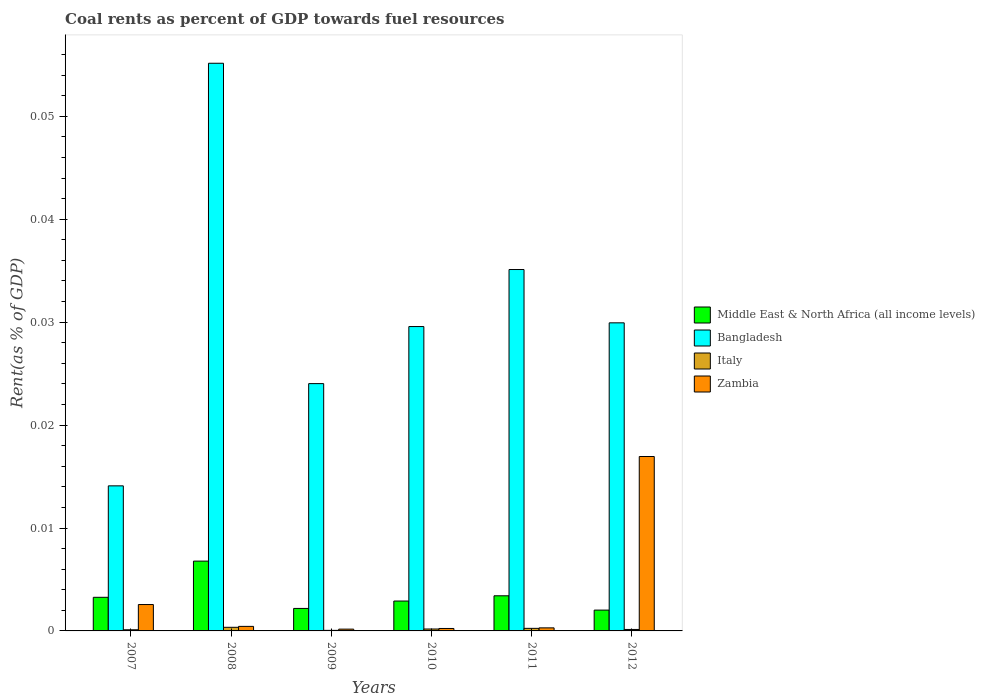How many different coloured bars are there?
Keep it short and to the point. 4. Are the number of bars per tick equal to the number of legend labels?
Offer a terse response. Yes. How many bars are there on the 6th tick from the left?
Keep it short and to the point. 4. How many bars are there on the 1st tick from the right?
Your answer should be very brief. 4. What is the coal rent in Bangladesh in 2007?
Offer a terse response. 0.01. Across all years, what is the maximum coal rent in Bangladesh?
Your answer should be very brief. 0.06. Across all years, what is the minimum coal rent in Italy?
Give a very brief answer. 5.380155600468061e-5. In which year was the coal rent in Italy maximum?
Your response must be concise. 2008. What is the total coal rent in Bangladesh in the graph?
Offer a terse response. 0.19. What is the difference between the coal rent in Italy in 2009 and that in 2011?
Your response must be concise. -0. What is the difference between the coal rent in Bangladesh in 2008 and the coal rent in Middle East & North Africa (all income levels) in 2009?
Offer a terse response. 0.05. What is the average coal rent in Italy per year?
Provide a succinct answer. 0. In the year 2012, what is the difference between the coal rent in Italy and coal rent in Zambia?
Keep it short and to the point. -0.02. In how many years, is the coal rent in Italy greater than 0.052000000000000005 %?
Make the answer very short. 0. What is the ratio of the coal rent in Italy in 2010 to that in 2011?
Offer a very short reply. 0.75. Is the coal rent in Bangladesh in 2010 less than that in 2012?
Offer a terse response. Yes. Is the difference between the coal rent in Italy in 2007 and 2010 greater than the difference between the coal rent in Zambia in 2007 and 2010?
Your answer should be very brief. No. What is the difference between the highest and the second highest coal rent in Bangladesh?
Your answer should be very brief. 0.02. What is the difference between the highest and the lowest coal rent in Zambia?
Your answer should be compact. 0.02. In how many years, is the coal rent in Italy greater than the average coal rent in Italy taken over all years?
Give a very brief answer. 3. Is the sum of the coal rent in Bangladesh in 2008 and 2009 greater than the maximum coal rent in Middle East & North Africa (all income levels) across all years?
Your answer should be very brief. Yes. Is it the case that in every year, the sum of the coal rent in Zambia and coal rent in Bangladesh is greater than the sum of coal rent in Italy and coal rent in Middle East & North Africa (all income levels)?
Provide a short and direct response. Yes. What does the 1st bar from the left in 2010 represents?
Your answer should be very brief. Middle East & North Africa (all income levels). What does the 1st bar from the right in 2007 represents?
Keep it short and to the point. Zambia. How many years are there in the graph?
Provide a short and direct response. 6. What is the difference between two consecutive major ticks on the Y-axis?
Ensure brevity in your answer.  0.01. Are the values on the major ticks of Y-axis written in scientific E-notation?
Provide a short and direct response. No. Does the graph contain any zero values?
Offer a terse response. No. Where does the legend appear in the graph?
Offer a terse response. Center right. How many legend labels are there?
Give a very brief answer. 4. How are the legend labels stacked?
Make the answer very short. Vertical. What is the title of the graph?
Offer a terse response. Coal rents as percent of GDP towards fuel resources. What is the label or title of the X-axis?
Make the answer very short. Years. What is the label or title of the Y-axis?
Your response must be concise. Rent(as % of GDP). What is the Rent(as % of GDP) of Middle East & North Africa (all income levels) in 2007?
Make the answer very short. 0. What is the Rent(as % of GDP) of Bangladesh in 2007?
Your answer should be very brief. 0.01. What is the Rent(as % of GDP) of Italy in 2007?
Keep it short and to the point. 0. What is the Rent(as % of GDP) of Zambia in 2007?
Offer a terse response. 0. What is the Rent(as % of GDP) in Middle East & North Africa (all income levels) in 2008?
Your answer should be very brief. 0.01. What is the Rent(as % of GDP) in Bangladesh in 2008?
Give a very brief answer. 0.06. What is the Rent(as % of GDP) in Italy in 2008?
Ensure brevity in your answer.  0. What is the Rent(as % of GDP) in Zambia in 2008?
Offer a terse response. 0. What is the Rent(as % of GDP) in Middle East & North Africa (all income levels) in 2009?
Ensure brevity in your answer.  0. What is the Rent(as % of GDP) of Bangladesh in 2009?
Your answer should be compact. 0.02. What is the Rent(as % of GDP) of Italy in 2009?
Give a very brief answer. 5.380155600468061e-5. What is the Rent(as % of GDP) in Zambia in 2009?
Your answer should be very brief. 0. What is the Rent(as % of GDP) in Middle East & North Africa (all income levels) in 2010?
Provide a short and direct response. 0. What is the Rent(as % of GDP) of Bangladesh in 2010?
Give a very brief answer. 0.03. What is the Rent(as % of GDP) in Italy in 2010?
Your response must be concise. 0. What is the Rent(as % of GDP) in Zambia in 2010?
Provide a short and direct response. 0. What is the Rent(as % of GDP) of Middle East & North Africa (all income levels) in 2011?
Give a very brief answer. 0. What is the Rent(as % of GDP) in Bangladesh in 2011?
Ensure brevity in your answer.  0.04. What is the Rent(as % of GDP) of Italy in 2011?
Make the answer very short. 0. What is the Rent(as % of GDP) in Zambia in 2011?
Keep it short and to the point. 0. What is the Rent(as % of GDP) in Middle East & North Africa (all income levels) in 2012?
Ensure brevity in your answer.  0. What is the Rent(as % of GDP) in Bangladesh in 2012?
Offer a terse response. 0.03. What is the Rent(as % of GDP) of Italy in 2012?
Your answer should be compact. 0. What is the Rent(as % of GDP) of Zambia in 2012?
Keep it short and to the point. 0.02. Across all years, what is the maximum Rent(as % of GDP) of Middle East & North Africa (all income levels)?
Provide a short and direct response. 0.01. Across all years, what is the maximum Rent(as % of GDP) of Bangladesh?
Provide a short and direct response. 0.06. Across all years, what is the maximum Rent(as % of GDP) of Italy?
Offer a terse response. 0. Across all years, what is the maximum Rent(as % of GDP) of Zambia?
Your response must be concise. 0.02. Across all years, what is the minimum Rent(as % of GDP) of Middle East & North Africa (all income levels)?
Provide a succinct answer. 0. Across all years, what is the minimum Rent(as % of GDP) of Bangladesh?
Offer a very short reply. 0.01. Across all years, what is the minimum Rent(as % of GDP) of Italy?
Provide a short and direct response. 5.380155600468061e-5. Across all years, what is the minimum Rent(as % of GDP) of Zambia?
Ensure brevity in your answer.  0. What is the total Rent(as % of GDP) of Middle East & North Africa (all income levels) in the graph?
Your response must be concise. 0.02. What is the total Rent(as % of GDP) of Bangladesh in the graph?
Make the answer very short. 0.19. What is the total Rent(as % of GDP) of Italy in the graph?
Your answer should be very brief. 0. What is the total Rent(as % of GDP) in Zambia in the graph?
Ensure brevity in your answer.  0.02. What is the difference between the Rent(as % of GDP) in Middle East & North Africa (all income levels) in 2007 and that in 2008?
Your answer should be very brief. -0. What is the difference between the Rent(as % of GDP) of Bangladesh in 2007 and that in 2008?
Your response must be concise. -0.04. What is the difference between the Rent(as % of GDP) in Italy in 2007 and that in 2008?
Offer a terse response. -0. What is the difference between the Rent(as % of GDP) in Zambia in 2007 and that in 2008?
Offer a terse response. 0. What is the difference between the Rent(as % of GDP) in Middle East & North Africa (all income levels) in 2007 and that in 2009?
Offer a very short reply. 0. What is the difference between the Rent(as % of GDP) of Bangladesh in 2007 and that in 2009?
Offer a very short reply. -0.01. What is the difference between the Rent(as % of GDP) of Zambia in 2007 and that in 2009?
Offer a very short reply. 0. What is the difference between the Rent(as % of GDP) of Middle East & North Africa (all income levels) in 2007 and that in 2010?
Offer a terse response. 0. What is the difference between the Rent(as % of GDP) of Bangladesh in 2007 and that in 2010?
Provide a short and direct response. -0.02. What is the difference between the Rent(as % of GDP) of Italy in 2007 and that in 2010?
Your answer should be compact. -0. What is the difference between the Rent(as % of GDP) in Zambia in 2007 and that in 2010?
Keep it short and to the point. 0. What is the difference between the Rent(as % of GDP) in Middle East & North Africa (all income levels) in 2007 and that in 2011?
Keep it short and to the point. -0. What is the difference between the Rent(as % of GDP) of Bangladesh in 2007 and that in 2011?
Your response must be concise. -0.02. What is the difference between the Rent(as % of GDP) in Italy in 2007 and that in 2011?
Ensure brevity in your answer.  -0. What is the difference between the Rent(as % of GDP) of Zambia in 2007 and that in 2011?
Offer a very short reply. 0. What is the difference between the Rent(as % of GDP) of Middle East & North Africa (all income levels) in 2007 and that in 2012?
Make the answer very short. 0. What is the difference between the Rent(as % of GDP) of Bangladesh in 2007 and that in 2012?
Offer a very short reply. -0.02. What is the difference between the Rent(as % of GDP) of Italy in 2007 and that in 2012?
Offer a very short reply. -0. What is the difference between the Rent(as % of GDP) in Zambia in 2007 and that in 2012?
Keep it short and to the point. -0.01. What is the difference between the Rent(as % of GDP) in Middle East & North Africa (all income levels) in 2008 and that in 2009?
Provide a succinct answer. 0. What is the difference between the Rent(as % of GDP) of Bangladesh in 2008 and that in 2009?
Offer a terse response. 0.03. What is the difference between the Rent(as % of GDP) of Italy in 2008 and that in 2009?
Keep it short and to the point. 0. What is the difference between the Rent(as % of GDP) in Zambia in 2008 and that in 2009?
Give a very brief answer. 0. What is the difference between the Rent(as % of GDP) of Middle East & North Africa (all income levels) in 2008 and that in 2010?
Give a very brief answer. 0. What is the difference between the Rent(as % of GDP) in Bangladesh in 2008 and that in 2010?
Ensure brevity in your answer.  0.03. What is the difference between the Rent(as % of GDP) in Middle East & North Africa (all income levels) in 2008 and that in 2011?
Ensure brevity in your answer.  0. What is the difference between the Rent(as % of GDP) in Italy in 2008 and that in 2011?
Your answer should be compact. 0. What is the difference between the Rent(as % of GDP) of Middle East & North Africa (all income levels) in 2008 and that in 2012?
Keep it short and to the point. 0. What is the difference between the Rent(as % of GDP) in Bangladesh in 2008 and that in 2012?
Offer a terse response. 0.03. What is the difference between the Rent(as % of GDP) of Zambia in 2008 and that in 2012?
Offer a very short reply. -0.02. What is the difference between the Rent(as % of GDP) in Middle East & North Africa (all income levels) in 2009 and that in 2010?
Offer a terse response. -0. What is the difference between the Rent(as % of GDP) of Bangladesh in 2009 and that in 2010?
Ensure brevity in your answer.  -0.01. What is the difference between the Rent(as % of GDP) in Italy in 2009 and that in 2010?
Give a very brief answer. -0. What is the difference between the Rent(as % of GDP) of Zambia in 2009 and that in 2010?
Make the answer very short. -0. What is the difference between the Rent(as % of GDP) of Middle East & North Africa (all income levels) in 2009 and that in 2011?
Ensure brevity in your answer.  -0. What is the difference between the Rent(as % of GDP) in Bangladesh in 2009 and that in 2011?
Your response must be concise. -0.01. What is the difference between the Rent(as % of GDP) of Italy in 2009 and that in 2011?
Your answer should be compact. -0. What is the difference between the Rent(as % of GDP) in Zambia in 2009 and that in 2011?
Make the answer very short. -0. What is the difference between the Rent(as % of GDP) in Bangladesh in 2009 and that in 2012?
Keep it short and to the point. -0.01. What is the difference between the Rent(as % of GDP) in Italy in 2009 and that in 2012?
Make the answer very short. -0. What is the difference between the Rent(as % of GDP) of Zambia in 2009 and that in 2012?
Offer a very short reply. -0.02. What is the difference between the Rent(as % of GDP) of Middle East & North Africa (all income levels) in 2010 and that in 2011?
Offer a very short reply. -0. What is the difference between the Rent(as % of GDP) of Bangladesh in 2010 and that in 2011?
Offer a very short reply. -0.01. What is the difference between the Rent(as % of GDP) in Italy in 2010 and that in 2011?
Your answer should be very brief. -0. What is the difference between the Rent(as % of GDP) of Zambia in 2010 and that in 2011?
Make the answer very short. -0. What is the difference between the Rent(as % of GDP) in Middle East & North Africa (all income levels) in 2010 and that in 2012?
Offer a terse response. 0. What is the difference between the Rent(as % of GDP) of Bangladesh in 2010 and that in 2012?
Your response must be concise. -0. What is the difference between the Rent(as % of GDP) in Italy in 2010 and that in 2012?
Provide a succinct answer. 0. What is the difference between the Rent(as % of GDP) in Zambia in 2010 and that in 2012?
Provide a short and direct response. -0.02. What is the difference between the Rent(as % of GDP) in Middle East & North Africa (all income levels) in 2011 and that in 2012?
Give a very brief answer. 0. What is the difference between the Rent(as % of GDP) of Bangladesh in 2011 and that in 2012?
Your answer should be compact. 0.01. What is the difference between the Rent(as % of GDP) in Zambia in 2011 and that in 2012?
Offer a terse response. -0.02. What is the difference between the Rent(as % of GDP) of Middle East & North Africa (all income levels) in 2007 and the Rent(as % of GDP) of Bangladesh in 2008?
Your answer should be compact. -0.05. What is the difference between the Rent(as % of GDP) of Middle East & North Africa (all income levels) in 2007 and the Rent(as % of GDP) of Italy in 2008?
Your answer should be compact. 0. What is the difference between the Rent(as % of GDP) of Middle East & North Africa (all income levels) in 2007 and the Rent(as % of GDP) of Zambia in 2008?
Your answer should be very brief. 0. What is the difference between the Rent(as % of GDP) of Bangladesh in 2007 and the Rent(as % of GDP) of Italy in 2008?
Make the answer very short. 0.01. What is the difference between the Rent(as % of GDP) in Bangladesh in 2007 and the Rent(as % of GDP) in Zambia in 2008?
Your answer should be very brief. 0.01. What is the difference between the Rent(as % of GDP) in Italy in 2007 and the Rent(as % of GDP) in Zambia in 2008?
Give a very brief answer. -0. What is the difference between the Rent(as % of GDP) in Middle East & North Africa (all income levels) in 2007 and the Rent(as % of GDP) in Bangladesh in 2009?
Provide a short and direct response. -0.02. What is the difference between the Rent(as % of GDP) in Middle East & North Africa (all income levels) in 2007 and the Rent(as % of GDP) in Italy in 2009?
Your answer should be very brief. 0. What is the difference between the Rent(as % of GDP) in Middle East & North Africa (all income levels) in 2007 and the Rent(as % of GDP) in Zambia in 2009?
Give a very brief answer. 0. What is the difference between the Rent(as % of GDP) of Bangladesh in 2007 and the Rent(as % of GDP) of Italy in 2009?
Give a very brief answer. 0.01. What is the difference between the Rent(as % of GDP) of Bangladesh in 2007 and the Rent(as % of GDP) of Zambia in 2009?
Offer a terse response. 0.01. What is the difference between the Rent(as % of GDP) of Italy in 2007 and the Rent(as % of GDP) of Zambia in 2009?
Provide a short and direct response. -0. What is the difference between the Rent(as % of GDP) in Middle East & North Africa (all income levels) in 2007 and the Rent(as % of GDP) in Bangladesh in 2010?
Your answer should be very brief. -0.03. What is the difference between the Rent(as % of GDP) of Middle East & North Africa (all income levels) in 2007 and the Rent(as % of GDP) of Italy in 2010?
Provide a short and direct response. 0. What is the difference between the Rent(as % of GDP) in Middle East & North Africa (all income levels) in 2007 and the Rent(as % of GDP) in Zambia in 2010?
Your response must be concise. 0. What is the difference between the Rent(as % of GDP) in Bangladesh in 2007 and the Rent(as % of GDP) in Italy in 2010?
Provide a succinct answer. 0.01. What is the difference between the Rent(as % of GDP) of Bangladesh in 2007 and the Rent(as % of GDP) of Zambia in 2010?
Provide a short and direct response. 0.01. What is the difference between the Rent(as % of GDP) of Italy in 2007 and the Rent(as % of GDP) of Zambia in 2010?
Offer a terse response. -0. What is the difference between the Rent(as % of GDP) of Middle East & North Africa (all income levels) in 2007 and the Rent(as % of GDP) of Bangladesh in 2011?
Make the answer very short. -0.03. What is the difference between the Rent(as % of GDP) in Middle East & North Africa (all income levels) in 2007 and the Rent(as % of GDP) in Italy in 2011?
Offer a terse response. 0. What is the difference between the Rent(as % of GDP) of Middle East & North Africa (all income levels) in 2007 and the Rent(as % of GDP) of Zambia in 2011?
Provide a short and direct response. 0. What is the difference between the Rent(as % of GDP) in Bangladesh in 2007 and the Rent(as % of GDP) in Italy in 2011?
Make the answer very short. 0.01. What is the difference between the Rent(as % of GDP) in Bangladesh in 2007 and the Rent(as % of GDP) in Zambia in 2011?
Your answer should be very brief. 0.01. What is the difference between the Rent(as % of GDP) in Italy in 2007 and the Rent(as % of GDP) in Zambia in 2011?
Give a very brief answer. -0. What is the difference between the Rent(as % of GDP) in Middle East & North Africa (all income levels) in 2007 and the Rent(as % of GDP) in Bangladesh in 2012?
Provide a succinct answer. -0.03. What is the difference between the Rent(as % of GDP) in Middle East & North Africa (all income levels) in 2007 and the Rent(as % of GDP) in Italy in 2012?
Provide a short and direct response. 0. What is the difference between the Rent(as % of GDP) in Middle East & North Africa (all income levels) in 2007 and the Rent(as % of GDP) in Zambia in 2012?
Make the answer very short. -0.01. What is the difference between the Rent(as % of GDP) of Bangladesh in 2007 and the Rent(as % of GDP) of Italy in 2012?
Ensure brevity in your answer.  0.01. What is the difference between the Rent(as % of GDP) of Bangladesh in 2007 and the Rent(as % of GDP) of Zambia in 2012?
Provide a succinct answer. -0. What is the difference between the Rent(as % of GDP) in Italy in 2007 and the Rent(as % of GDP) in Zambia in 2012?
Offer a terse response. -0.02. What is the difference between the Rent(as % of GDP) of Middle East & North Africa (all income levels) in 2008 and the Rent(as % of GDP) of Bangladesh in 2009?
Ensure brevity in your answer.  -0.02. What is the difference between the Rent(as % of GDP) in Middle East & North Africa (all income levels) in 2008 and the Rent(as % of GDP) in Italy in 2009?
Offer a very short reply. 0.01. What is the difference between the Rent(as % of GDP) of Middle East & North Africa (all income levels) in 2008 and the Rent(as % of GDP) of Zambia in 2009?
Your answer should be very brief. 0.01. What is the difference between the Rent(as % of GDP) in Bangladesh in 2008 and the Rent(as % of GDP) in Italy in 2009?
Your response must be concise. 0.06. What is the difference between the Rent(as % of GDP) in Bangladesh in 2008 and the Rent(as % of GDP) in Zambia in 2009?
Offer a very short reply. 0.06. What is the difference between the Rent(as % of GDP) in Italy in 2008 and the Rent(as % of GDP) in Zambia in 2009?
Provide a succinct answer. 0. What is the difference between the Rent(as % of GDP) of Middle East & North Africa (all income levels) in 2008 and the Rent(as % of GDP) of Bangladesh in 2010?
Your answer should be very brief. -0.02. What is the difference between the Rent(as % of GDP) in Middle East & North Africa (all income levels) in 2008 and the Rent(as % of GDP) in Italy in 2010?
Your answer should be compact. 0.01. What is the difference between the Rent(as % of GDP) in Middle East & North Africa (all income levels) in 2008 and the Rent(as % of GDP) in Zambia in 2010?
Keep it short and to the point. 0.01. What is the difference between the Rent(as % of GDP) in Bangladesh in 2008 and the Rent(as % of GDP) in Italy in 2010?
Offer a terse response. 0.06. What is the difference between the Rent(as % of GDP) in Bangladesh in 2008 and the Rent(as % of GDP) in Zambia in 2010?
Your answer should be very brief. 0.05. What is the difference between the Rent(as % of GDP) of Middle East & North Africa (all income levels) in 2008 and the Rent(as % of GDP) of Bangladesh in 2011?
Make the answer very short. -0.03. What is the difference between the Rent(as % of GDP) of Middle East & North Africa (all income levels) in 2008 and the Rent(as % of GDP) of Italy in 2011?
Keep it short and to the point. 0.01. What is the difference between the Rent(as % of GDP) in Middle East & North Africa (all income levels) in 2008 and the Rent(as % of GDP) in Zambia in 2011?
Your answer should be compact. 0.01. What is the difference between the Rent(as % of GDP) of Bangladesh in 2008 and the Rent(as % of GDP) of Italy in 2011?
Provide a succinct answer. 0.05. What is the difference between the Rent(as % of GDP) of Bangladesh in 2008 and the Rent(as % of GDP) of Zambia in 2011?
Your answer should be compact. 0.05. What is the difference between the Rent(as % of GDP) in Italy in 2008 and the Rent(as % of GDP) in Zambia in 2011?
Keep it short and to the point. 0. What is the difference between the Rent(as % of GDP) in Middle East & North Africa (all income levels) in 2008 and the Rent(as % of GDP) in Bangladesh in 2012?
Give a very brief answer. -0.02. What is the difference between the Rent(as % of GDP) of Middle East & North Africa (all income levels) in 2008 and the Rent(as % of GDP) of Italy in 2012?
Provide a short and direct response. 0.01. What is the difference between the Rent(as % of GDP) in Middle East & North Africa (all income levels) in 2008 and the Rent(as % of GDP) in Zambia in 2012?
Offer a very short reply. -0.01. What is the difference between the Rent(as % of GDP) of Bangladesh in 2008 and the Rent(as % of GDP) of Italy in 2012?
Give a very brief answer. 0.06. What is the difference between the Rent(as % of GDP) of Bangladesh in 2008 and the Rent(as % of GDP) of Zambia in 2012?
Your response must be concise. 0.04. What is the difference between the Rent(as % of GDP) in Italy in 2008 and the Rent(as % of GDP) in Zambia in 2012?
Your response must be concise. -0.02. What is the difference between the Rent(as % of GDP) of Middle East & North Africa (all income levels) in 2009 and the Rent(as % of GDP) of Bangladesh in 2010?
Your response must be concise. -0.03. What is the difference between the Rent(as % of GDP) in Middle East & North Africa (all income levels) in 2009 and the Rent(as % of GDP) in Italy in 2010?
Your answer should be very brief. 0. What is the difference between the Rent(as % of GDP) in Middle East & North Africa (all income levels) in 2009 and the Rent(as % of GDP) in Zambia in 2010?
Keep it short and to the point. 0. What is the difference between the Rent(as % of GDP) in Bangladesh in 2009 and the Rent(as % of GDP) in Italy in 2010?
Your response must be concise. 0.02. What is the difference between the Rent(as % of GDP) in Bangladesh in 2009 and the Rent(as % of GDP) in Zambia in 2010?
Keep it short and to the point. 0.02. What is the difference between the Rent(as % of GDP) in Italy in 2009 and the Rent(as % of GDP) in Zambia in 2010?
Provide a short and direct response. -0. What is the difference between the Rent(as % of GDP) of Middle East & North Africa (all income levels) in 2009 and the Rent(as % of GDP) of Bangladesh in 2011?
Offer a terse response. -0.03. What is the difference between the Rent(as % of GDP) in Middle East & North Africa (all income levels) in 2009 and the Rent(as % of GDP) in Italy in 2011?
Your answer should be compact. 0. What is the difference between the Rent(as % of GDP) of Middle East & North Africa (all income levels) in 2009 and the Rent(as % of GDP) of Zambia in 2011?
Offer a very short reply. 0. What is the difference between the Rent(as % of GDP) in Bangladesh in 2009 and the Rent(as % of GDP) in Italy in 2011?
Ensure brevity in your answer.  0.02. What is the difference between the Rent(as % of GDP) in Bangladesh in 2009 and the Rent(as % of GDP) in Zambia in 2011?
Your answer should be very brief. 0.02. What is the difference between the Rent(as % of GDP) in Italy in 2009 and the Rent(as % of GDP) in Zambia in 2011?
Keep it short and to the point. -0. What is the difference between the Rent(as % of GDP) in Middle East & North Africa (all income levels) in 2009 and the Rent(as % of GDP) in Bangladesh in 2012?
Your response must be concise. -0.03. What is the difference between the Rent(as % of GDP) of Middle East & North Africa (all income levels) in 2009 and the Rent(as % of GDP) of Italy in 2012?
Keep it short and to the point. 0. What is the difference between the Rent(as % of GDP) in Middle East & North Africa (all income levels) in 2009 and the Rent(as % of GDP) in Zambia in 2012?
Offer a very short reply. -0.01. What is the difference between the Rent(as % of GDP) in Bangladesh in 2009 and the Rent(as % of GDP) in Italy in 2012?
Your answer should be compact. 0.02. What is the difference between the Rent(as % of GDP) in Bangladesh in 2009 and the Rent(as % of GDP) in Zambia in 2012?
Give a very brief answer. 0.01. What is the difference between the Rent(as % of GDP) of Italy in 2009 and the Rent(as % of GDP) of Zambia in 2012?
Give a very brief answer. -0.02. What is the difference between the Rent(as % of GDP) in Middle East & North Africa (all income levels) in 2010 and the Rent(as % of GDP) in Bangladesh in 2011?
Your answer should be compact. -0.03. What is the difference between the Rent(as % of GDP) of Middle East & North Africa (all income levels) in 2010 and the Rent(as % of GDP) of Italy in 2011?
Your answer should be compact. 0. What is the difference between the Rent(as % of GDP) of Middle East & North Africa (all income levels) in 2010 and the Rent(as % of GDP) of Zambia in 2011?
Offer a very short reply. 0. What is the difference between the Rent(as % of GDP) of Bangladesh in 2010 and the Rent(as % of GDP) of Italy in 2011?
Provide a succinct answer. 0.03. What is the difference between the Rent(as % of GDP) in Bangladesh in 2010 and the Rent(as % of GDP) in Zambia in 2011?
Offer a terse response. 0.03. What is the difference between the Rent(as % of GDP) in Italy in 2010 and the Rent(as % of GDP) in Zambia in 2011?
Provide a succinct answer. -0. What is the difference between the Rent(as % of GDP) in Middle East & North Africa (all income levels) in 2010 and the Rent(as % of GDP) in Bangladesh in 2012?
Give a very brief answer. -0.03. What is the difference between the Rent(as % of GDP) in Middle East & North Africa (all income levels) in 2010 and the Rent(as % of GDP) in Italy in 2012?
Provide a succinct answer. 0. What is the difference between the Rent(as % of GDP) of Middle East & North Africa (all income levels) in 2010 and the Rent(as % of GDP) of Zambia in 2012?
Ensure brevity in your answer.  -0.01. What is the difference between the Rent(as % of GDP) of Bangladesh in 2010 and the Rent(as % of GDP) of Italy in 2012?
Offer a very short reply. 0.03. What is the difference between the Rent(as % of GDP) in Bangladesh in 2010 and the Rent(as % of GDP) in Zambia in 2012?
Make the answer very short. 0.01. What is the difference between the Rent(as % of GDP) in Italy in 2010 and the Rent(as % of GDP) in Zambia in 2012?
Your response must be concise. -0.02. What is the difference between the Rent(as % of GDP) in Middle East & North Africa (all income levels) in 2011 and the Rent(as % of GDP) in Bangladesh in 2012?
Offer a very short reply. -0.03. What is the difference between the Rent(as % of GDP) of Middle East & North Africa (all income levels) in 2011 and the Rent(as % of GDP) of Italy in 2012?
Provide a succinct answer. 0. What is the difference between the Rent(as % of GDP) in Middle East & North Africa (all income levels) in 2011 and the Rent(as % of GDP) in Zambia in 2012?
Make the answer very short. -0.01. What is the difference between the Rent(as % of GDP) of Bangladesh in 2011 and the Rent(as % of GDP) of Italy in 2012?
Provide a succinct answer. 0.04. What is the difference between the Rent(as % of GDP) of Bangladesh in 2011 and the Rent(as % of GDP) of Zambia in 2012?
Your response must be concise. 0.02. What is the difference between the Rent(as % of GDP) in Italy in 2011 and the Rent(as % of GDP) in Zambia in 2012?
Your response must be concise. -0.02. What is the average Rent(as % of GDP) of Middle East & North Africa (all income levels) per year?
Give a very brief answer. 0. What is the average Rent(as % of GDP) in Bangladesh per year?
Your answer should be compact. 0.03. What is the average Rent(as % of GDP) in Italy per year?
Provide a short and direct response. 0. What is the average Rent(as % of GDP) of Zambia per year?
Keep it short and to the point. 0. In the year 2007, what is the difference between the Rent(as % of GDP) in Middle East & North Africa (all income levels) and Rent(as % of GDP) in Bangladesh?
Provide a short and direct response. -0.01. In the year 2007, what is the difference between the Rent(as % of GDP) of Middle East & North Africa (all income levels) and Rent(as % of GDP) of Italy?
Provide a succinct answer. 0. In the year 2007, what is the difference between the Rent(as % of GDP) of Middle East & North Africa (all income levels) and Rent(as % of GDP) of Zambia?
Provide a succinct answer. 0. In the year 2007, what is the difference between the Rent(as % of GDP) of Bangladesh and Rent(as % of GDP) of Italy?
Your answer should be very brief. 0.01. In the year 2007, what is the difference between the Rent(as % of GDP) in Bangladesh and Rent(as % of GDP) in Zambia?
Your response must be concise. 0.01. In the year 2007, what is the difference between the Rent(as % of GDP) in Italy and Rent(as % of GDP) in Zambia?
Offer a terse response. -0. In the year 2008, what is the difference between the Rent(as % of GDP) of Middle East & North Africa (all income levels) and Rent(as % of GDP) of Bangladesh?
Provide a succinct answer. -0.05. In the year 2008, what is the difference between the Rent(as % of GDP) in Middle East & North Africa (all income levels) and Rent(as % of GDP) in Italy?
Offer a terse response. 0.01. In the year 2008, what is the difference between the Rent(as % of GDP) of Middle East & North Africa (all income levels) and Rent(as % of GDP) of Zambia?
Ensure brevity in your answer.  0.01. In the year 2008, what is the difference between the Rent(as % of GDP) in Bangladesh and Rent(as % of GDP) in Italy?
Ensure brevity in your answer.  0.05. In the year 2008, what is the difference between the Rent(as % of GDP) in Bangladesh and Rent(as % of GDP) in Zambia?
Provide a short and direct response. 0.05. In the year 2008, what is the difference between the Rent(as % of GDP) in Italy and Rent(as % of GDP) in Zambia?
Offer a very short reply. -0. In the year 2009, what is the difference between the Rent(as % of GDP) in Middle East & North Africa (all income levels) and Rent(as % of GDP) in Bangladesh?
Your response must be concise. -0.02. In the year 2009, what is the difference between the Rent(as % of GDP) of Middle East & North Africa (all income levels) and Rent(as % of GDP) of Italy?
Provide a short and direct response. 0. In the year 2009, what is the difference between the Rent(as % of GDP) in Middle East & North Africa (all income levels) and Rent(as % of GDP) in Zambia?
Provide a short and direct response. 0. In the year 2009, what is the difference between the Rent(as % of GDP) in Bangladesh and Rent(as % of GDP) in Italy?
Make the answer very short. 0.02. In the year 2009, what is the difference between the Rent(as % of GDP) in Bangladesh and Rent(as % of GDP) in Zambia?
Ensure brevity in your answer.  0.02. In the year 2009, what is the difference between the Rent(as % of GDP) of Italy and Rent(as % of GDP) of Zambia?
Make the answer very short. -0. In the year 2010, what is the difference between the Rent(as % of GDP) of Middle East & North Africa (all income levels) and Rent(as % of GDP) of Bangladesh?
Your response must be concise. -0.03. In the year 2010, what is the difference between the Rent(as % of GDP) in Middle East & North Africa (all income levels) and Rent(as % of GDP) in Italy?
Provide a short and direct response. 0. In the year 2010, what is the difference between the Rent(as % of GDP) in Middle East & North Africa (all income levels) and Rent(as % of GDP) in Zambia?
Keep it short and to the point. 0. In the year 2010, what is the difference between the Rent(as % of GDP) of Bangladesh and Rent(as % of GDP) of Italy?
Provide a short and direct response. 0.03. In the year 2010, what is the difference between the Rent(as % of GDP) of Bangladesh and Rent(as % of GDP) of Zambia?
Give a very brief answer. 0.03. In the year 2010, what is the difference between the Rent(as % of GDP) of Italy and Rent(as % of GDP) of Zambia?
Offer a very short reply. -0. In the year 2011, what is the difference between the Rent(as % of GDP) in Middle East & North Africa (all income levels) and Rent(as % of GDP) in Bangladesh?
Keep it short and to the point. -0.03. In the year 2011, what is the difference between the Rent(as % of GDP) in Middle East & North Africa (all income levels) and Rent(as % of GDP) in Italy?
Make the answer very short. 0. In the year 2011, what is the difference between the Rent(as % of GDP) of Middle East & North Africa (all income levels) and Rent(as % of GDP) of Zambia?
Offer a terse response. 0. In the year 2011, what is the difference between the Rent(as % of GDP) in Bangladesh and Rent(as % of GDP) in Italy?
Your answer should be compact. 0.03. In the year 2011, what is the difference between the Rent(as % of GDP) of Bangladesh and Rent(as % of GDP) of Zambia?
Your answer should be very brief. 0.03. In the year 2012, what is the difference between the Rent(as % of GDP) of Middle East & North Africa (all income levels) and Rent(as % of GDP) of Bangladesh?
Your answer should be very brief. -0.03. In the year 2012, what is the difference between the Rent(as % of GDP) of Middle East & North Africa (all income levels) and Rent(as % of GDP) of Italy?
Give a very brief answer. 0. In the year 2012, what is the difference between the Rent(as % of GDP) of Middle East & North Africa (all income levels) and Rent(as % of GDP) of Zambia?
Provide a short and direct response. -0.01. In the year 2012, what is the difference between the Rent(as % of GDP) in Bangladesh and Rent(as % of GDP) in Italy?
Keep it short and to the point. 0.03. In the year 2012, what is the difference between the Rent(as % of GDP) of Bangladesh and Rent(as % of GDP) of Zambia?
Your answer should be very brief. 0.01. In the year 2012, what is the difference between the Rent(as % of GDP) in Italy and Rent(as % of GDP) in Zambia?
Ensure brevity in your answer.  -0.02. What is the ratio of the Rent(as % of GDP) of Middle East & North Africa (all income levels) in 2007 to that in 2008?
Provide a succinct answer. 0.48. What is the ratio of the Rent(as % of GDP) of Bangladesh in 2007 to that in 2008?
Offer a very short reply. 0.26. What is the ratio of the Rent(as % of GDP) in Italy in 2007 to that in 2008?
Your answer should be compact. 0.32. What is the ratio of the Rent(as % of GDP) in Zambia in 2007 to that in 2008?
Provide a succinct answer. 5.81. What is the ratio of the Rent(as % of GDP) of Middle East & North Africa (all income levels) in 2007 to that in 2009?
Your answer should be very brief. 1.49. What is the ratio of the Rent(as % of GDP) in Bangladesh in 2007 to that in 2009?
Offer a very short reply. 0.59. What is the ratio of the Rent(as % of GDP) in Italy in 2007 to that in 2009?
Offer a very short reply. 2.07. What is the ratio of the Rent(as % of GDP) of Zambia in 2007 to that in 2009?
Offer a terse response. 14.76. What is the ratio of the Rent(as % of GDP) of Middle East & North Africa (all income levels) in 2007 to that in 2010?
Your response must be concise. 1.13. What is the ratio of the Rent(as % of GDP) of Bangladesh in 2007 to that in 2010?
Make the answer very short. 0.48. What is the ratio of the Rent(as % of GDP) of Italy in 2007 to that in 2010?
Offer a terse response. 0.6. What is the ratio of the Rent(as % of GDP) of Zambia in 2007 to that in 2010?
Offer a terse response. 10.76. What is the ratio of the Rent(as % of GDP) in Middle East & North Africa (all income levels) in 2007 to that in 2011?
Your response must be concise. 0.96. What is the ratio of the Rent(as % of GDP) of Bangladesh in 2007 to that in 2011?
Provide a succinct answer. 0.4. What is the ratio of the Rent(as % of GDP) in Italy in 2007 to that in 2011?
Your answer should be very brief. 0.45. What is the ratio of the Rent(as % of GDP) of Zambia in 2007 to that in 2011?
Provide a succinct answer. 8.65. What is the ratio of the Rent(as % of GDP) of Middle East & North Africa (all income levels) in 2007 to that in 2012?
Give a very brief answer. 1.61. What is the ratio of the Rent(as % of GDP) of Bangladesh in 2007 to that in 2012?
Keep it short and to the point. 0.47. What is the ratio of the Rent(as % of GDP) of Italy in 2007 to that in 2012?
Make the answer very short. 0.78. What is the ratio of the Rent(as % of GDP) in Zambia in 2007 to that in 2012?
Offer a terse response. 0.15. What is the ratio of the Rent(as % of GDP) of Middle East & North Africa (all income levels) in 2008 to that in 2009?
Your answer should be compact. 3.1. What is the ratio of the Rent(as % of GDP) of Bangladesh in 2008 to that in 2009?
Your response must be concise. 2.3. What is the ratio of the Rent(as % of GDP) of Italy in 2008 to that in 2009?
Your answer should be very brief. 6.54. What is the ratio of the Rent(as % of GDP) in Zambia in 2008 to that in 2009?
Your answer should be compact. 2.54. What is the ratio of the Rent(as % of GDP) in Middle East & North Africa (all income levels) in 2008 to that in 2010?
Provide a succinct answer. 2.34. What is the ratio of the Rent(as % of GDP) of Bangladesh in 2008 to that in 2010?
Provide a short and direct response. 1.86. What is the ratio of the Rent(as % of GDP) of Italy in 2008 to that in 2010?
Provide a succinct answer. 1.89. What is the ratio of the Rent(as % of GDP) of Zambia in 2008 to that in 2010?
Ensure brevity in your answer.  1.85. What is the ratio of the Rent(as % of GDP) in Middle East & North Africa (all income levels) in 2008 to that in 2011?
Offer a very short reply. 1.99. What is the ratio of the Rent(as % of GDP) in Bangladesh in 2008 to that in 2011?
Keep it short and to the point. 1.57. What is the ratio of the Rent(as % of GDP) in Italy in 2008 to that in 2011?
Keep it short and to the point. 1.41. What is the ratio of the Rent(as % of GDP) in Zambia in 2008 to that in 2011?
Your answer should be very brief. 1.49. What is the ratio of the Rent(as % of GDP) in Middle East & North Africa (all income levels) in 2008 to that in 2012?
Ensure brevity in your answer.  3.35. What is the ratio of the Rent(as % of GDP) in Bangladesh in 2008 to that in 2012?
Provide a short and direct response. 1.84. What is the ratio of the Rent(as % of GDP) in Italy in 2008 to that in 2012?
Provide a short and direct response. 2.48. What is the ratio of the Rent(as % of GDP) in Zambia in 2008 to that in 2012?
Provide a succinct answer. 0.03. What is the ratio of the Rent(as % of GDP) of Middle East & North Africa (all income levels) in 2009 to that in 2010?
Your response must be concise. 0.75. What is the ratio of the Rent(as % of GDP) in Bangladesh in 2009 to that in 2010?
Offer a terse response. 0.81. What is the ratio of the Rent(as % of GDP) in Italy in 2009 to that in 2010?
Provide a succinct answer. 0.29. What is the ratio of the Rent(as % of GDP) in Zambia in 2009 to that in 2010?
Keep it short and to the point. 0.73. What is the ratio of the Rent(as % of GDP) in Middle East & North Africa (all income levels) in 2009 to that in 2011?
Your answer should be very brief. 0.64. What is the ratio of the Rent(as % of GDP) in Bangladesh in 2009 to that in 2011?
Provide a short and direct response. 0.68. What is the ratio of the Rent(as % of GDP) of Italy in 2009 to that in 2011?
Ensure brevity in your answer.  0.22. What is the ratio of the Rent(as % of GDP) of Zambia in 2009 to that in 2011?
Your answer should be very brief. 0.59. What is the ratio of the Rent(as % of GDP) in Middle East & North Africa (all income levels) in 2009 to that in 2012?
Provide a short and direct response. 1.08. What is the ratio of the Rent(as % of GDP) in Bangladesh in 2009 to that in 2012?
Provide a succinct answer. 0.8. What is the ratio of the Rent(as % of GDP) of Italy in 2009 to that in 2012?
Offer a very short reply. 0.38. What is the ratio of the Rent(as % of GDP) of Zambia in 2009 to that in 2012?
Ensure brevity in your answer.  0.01. What is the ratio of the Rent(as % of GDP) of Middle East & North Africa (all income levels) in 2010 to that in 2011?
Provide a succinct answer. 0.85. What is the ratio of the Rent(as % of GDP) of Bangladesh in 2010 to that in 2011?
Offer a terse response. 0.84. What is the ratio of the Rent(as % of GDP) of Italy in 2010 to that in 2011?
Provide a short and direct response. 0.75. What is the ratio of the Rent(as % of GDP) of Zambia in 2010 to that in 2011?
Provide a succinct answer. 0.8. What is the ratio of the Rent(as % of GDP) in Middle East & North Africa (all income levels) in 2010 to that in 2012?
Ensure brevity in your answer.  1.43. What is the ratio of the Rent(as % of GDP) of Italy in 2010 to that in 2012?
Keep it short and to the point. 1.31. What is the ratio of the Rent(as % of GDP) of Zambia in 2010 to that in 2012?
Your answer should be very brief. 0.01. What is the ratio of the Rent(as % of GDP) of Middle East & North Africa (all income levels) in 2011 to that in 2012?
Keep it short and to the point. 1.69. What is the ratio of the Rent(as % of GDP) in Bangladesh in 2011 to that in 2012?
Give a very brief answer. 1.17. What is the ratio of the Rent(as % of GDP) in Italy in 2011 to that in 2012?
Offer a very short reply. 1.76. What is the ratio of the Rent(as % of GDP) of Zambia in 2011 to that in 2012?
Ensure brevity in your answer.  0.02. What is the difference between the highest and the second highest Rent(as % of GDP) of Middle East & North Africa (all income levels)?
Keep it short and to the point. 0. What is the difference between the highest and the second highest Rent(as % of GDP) in Bangladesh?
Ensure brevity in your answer.  0.02. What is the difference between the highest and the second highest Rent(as % of GDP) in Zambia?
Offer a very short reply. 0.01. What is the difference between the highest and the lowest Rent(as % of GDP) of Middle East & North Africa (all income levels)?
Offer a terse response. 0. What is the difference between the highest and the lowest Rent(as % of GDP) of Bangladesh?
Provide a short and direct response. 0.04. What is the difference between the highest and the lowest Rent(as % of GDP) in Zambia?
Provide a short and direct response. 0.02. 